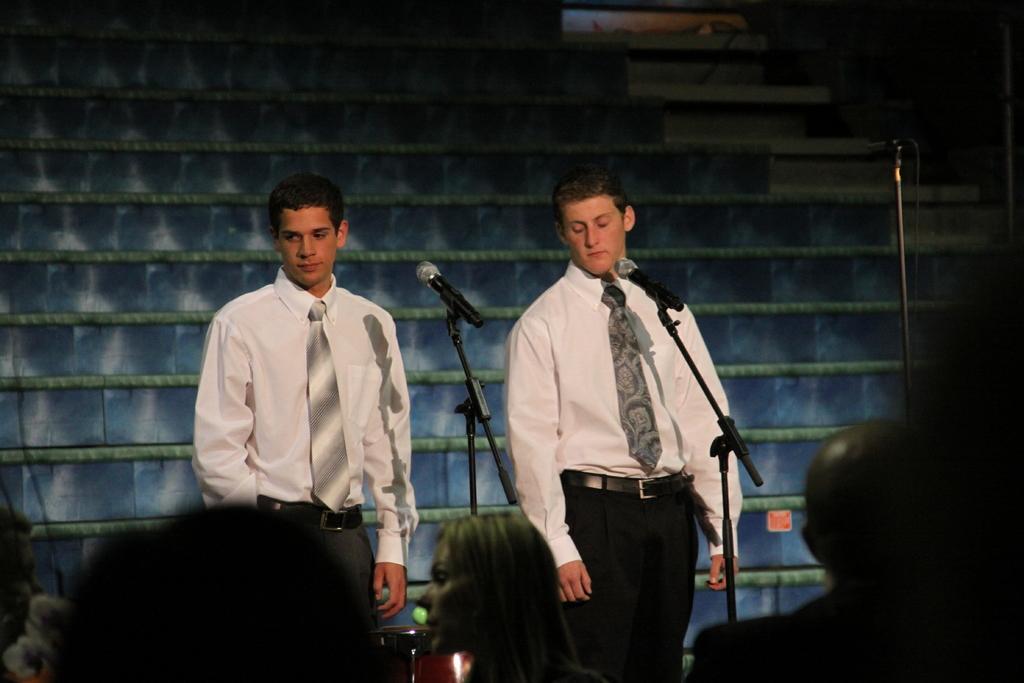How would you summarize this image in a sentence or two? This picture describes about group of people, in the middle of the given image we can see two men, they are standing and they wore white color shirts, in front of them we can see microphones and drums. 